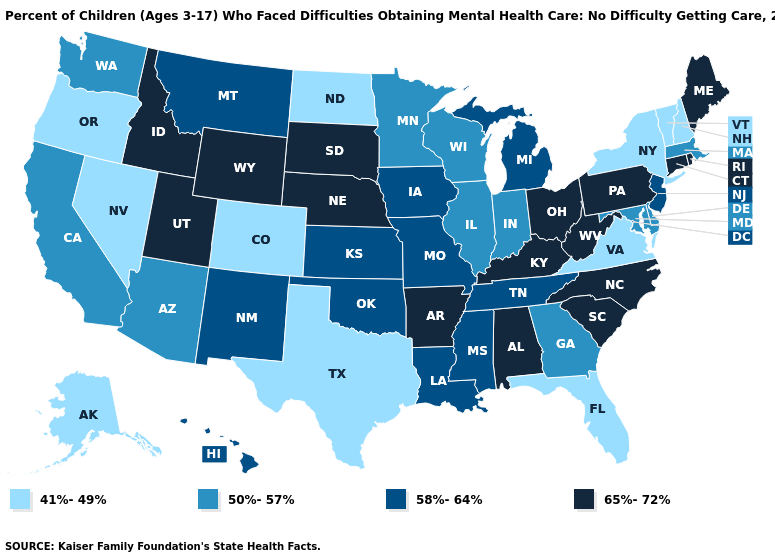What is the value of Nevada?
Concise answer only. 41%-49%. What is the value of New Jersey?
Give a very brief answer. 58%-64%. Which states have the lowest value in the USA?
Concise answer only. Alaska, Colorado, Florida, Nevada, New Hampshire, New York, North Dakota, Oregon, Texas, Vermont, Virginia. Does New York have the lowest value in the USA?
Be succinct. Yes. Name the states that have a value in the range 41%-49%?
Answer briefly. Alaska, Colorado, Florida, Nevada, New Hampshire, New York, North Dakota, Oregon, Texas, Vermont, Virginia. What is the value of Montana?
Answer briefly. 58%-64%. Name the states that have a value in the range 58%-64%?
Concise answer only. Hawaii, Iowa, Kansas, Louisiana, Michigan, Mississippi, Missouri, Montana, New Jersey, New Mexico, Oklahoma, Tennessee. What is the value of North Dakota?
Be succinct. 41%-49%. Name the states that have a value in the range 41%-49%?
Give a very brief answer. Alaska, Colorado, Florida, Nevada, New Hampshire, New York, North Dakota, Oregon, Texas, Vermont, Virginia. What is the value of North Dakota?
Short answer required. 41%-49%. Among the states that border Florida , which have the highest value?
Concise answer only. Alabama. Name the states that have a value in the range 65%-72%?
Be succinct. Alabama, Arkansas, Connecticut, Idaho, Kentucky, Maine, Nebraska, North Carolina, Ohio, Pennsylvania, Rhode Island, South Carolina, South Dakota, Utah, West Virginia, Wyoming. Name the states that have a value in the range 65%-72%?
Be succinct. Alabama, Arkansas, Connecticut, Idaho, Kentucky, Maine, Nebraska, North Carolina, Ohio, Pennsylvania, Rhode Island, South Carolina, South Dakota, Utah, West Virginia, Wyoming. Among the states that border Florida , which have the lowest value?
Short answer required. Georgia. What is the value of South Dakota?
Keep it brief. 65%-72%. 